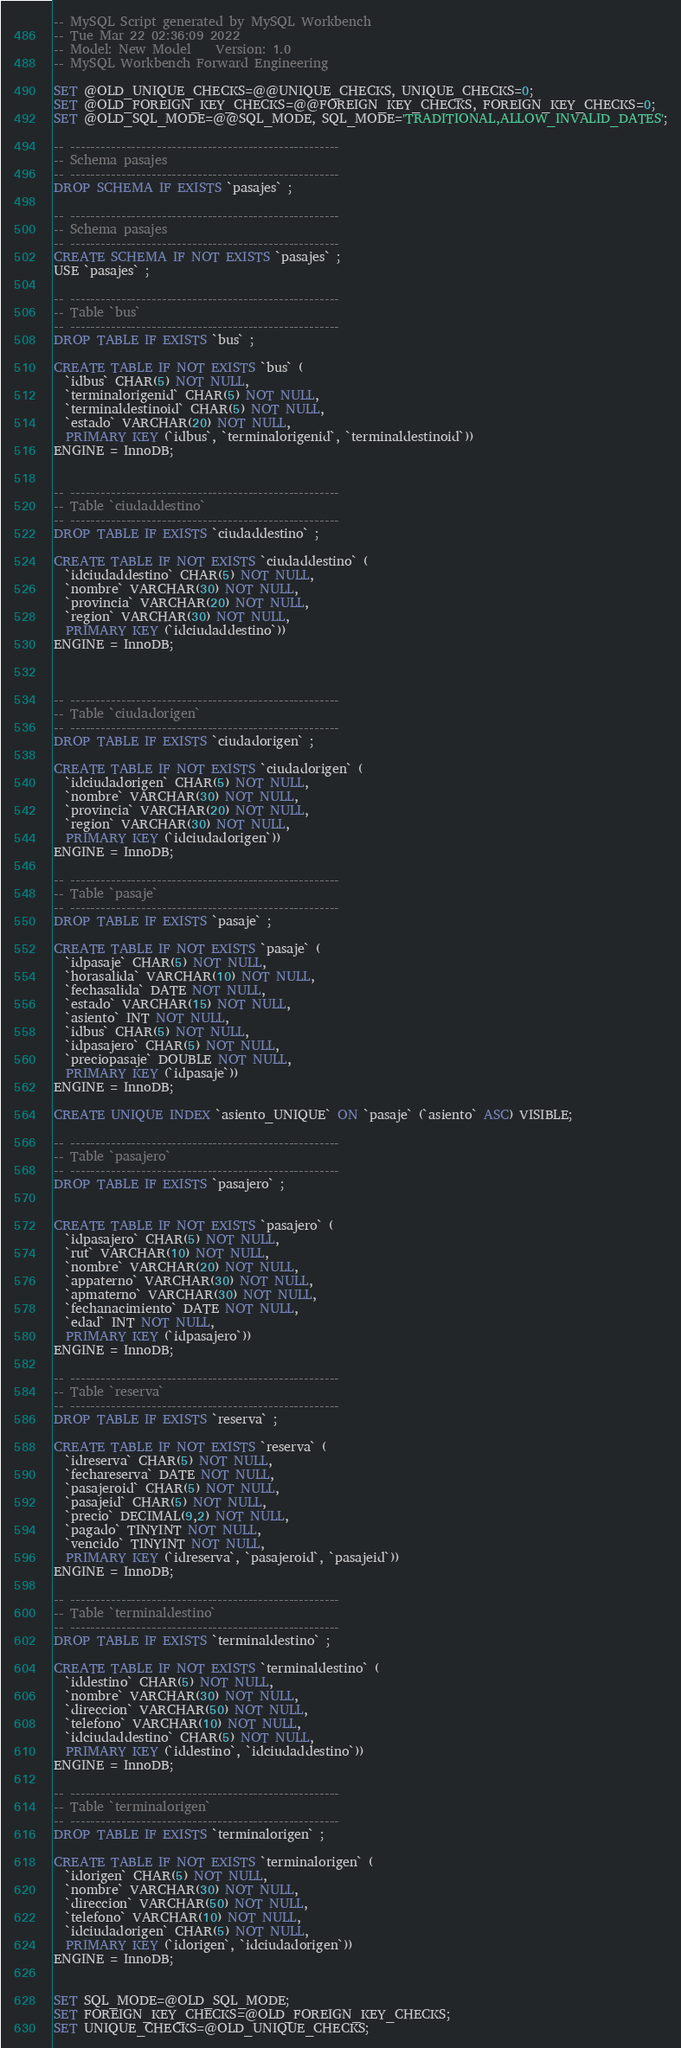Convert code to text. <code><loc_0><loc_0><loc_500><loc_500><_SQL_>-- MySQL Script generated by MySQL Workbench
-- Tue Mar 22 02:36:09 2022
-- Model: New Model    Version: 1.0
-- MySQL Workbench Forward Engineering

SET @OLD_UNIQUE_CHECKS=@@UNIQUE_CHECKS, UNIQUE_CHECKS=0;
SET @OLD_FOREIGN_KEY_CHECKS=@@FOREIGN_KEY_CHECKS, FOREIGN_KEY_CHECKS=0;
SET @OLD_SQL_MODE=@@SQL_MODE, SQL_MODE='TRADITIONAL,ALLOW_INVALID_DATES';

-- -----------------------------------------------------
-- Schema pasajes
-- -----------------------------------------------------
DROP SCHEMA IF EXISTS `pasajes` ;

-- -----------------------------------------------------
-- Schema pasajes
-- -----------------------------------------------------
CREATE SCHEMA IF NOT EXISTS `pasajes` ;
USE `pasajes` ;

-- -----------------------------------------------------
-- Table `bus`
-- -----------------------------------------------------
DROP TABLE IF EXISTS `bus` ;

CREATE TABLE IF NOT EXISTS `bus` (
  `idbus` CHAR(5) NOT NULL,
  `terminalorigenid` CHAR(5) NOT NULL,
  `terminaldestinoid` CHAR(5) NOT NULL,
  `estado` VARCHAR(20) NOT NULL,
  PRIMARY KEY (`idbus`, `terminalorigenid`, `terminaldestinoid`))
ENGINE = InnoDB;


-- -----------------------------------------------------
-- Table `ciudaddestino`
-- -----------------------------------------------------
DROP TABLE IF EXISTS `ciudaddestino` ;

CREATE TABLE IF NOT EXISTS `ciudaddestino` (
  `idciudaddestino` CHAR(5) NOT NULL,
  `nombre` VARCHAR(30) NOT NULL,
  `provincia` VARCHAR(20) NOT NULL,
  `region` VARCHAR(30) NOT NULL,
  PRIMARY KEY (`idciudaddestino`))
ENGINE = InnoDB;



-- -----------------------------------------------------
-- Table `ciudadorigen`
-- -----------------------------------------------------
DROP TABLE IF EXISTS `ciudadorigen` ;

CREATE TABLE IF NOT EXISTS `ciudadorigen` (
  `idciudadorigen` CHAR(5) NOT NULL,
  `nombre` VARCHAR(30) NOT NULL,
  `provincia` VARCHAR(20) NOT NULL,
  `region` VARCHAR(30) NOT NULL,
  PRIMARY KEY (`idciudadorigen`))
ENGINE = InnoDB;

-- -----------------------------------------------------
-- Table `pasaje`
-- -----------------------------------------------------
DROP TABLE IF EXISTS `pasaje` ;

CREATE TABLE IF NOT EXISTS `pasaje` (
  `idpasaje` CHAR(5) NOT NULL,
  `horasalida` VARCHAR(10) NOT NULL,
  `fechasalida` DATE NOT NULL,
  `estado` VARCHAR(15) NOT NULL,
  `asiento` INT NOT NULL,
  `idbus` CHAR(5) NOT NULL,
  `idpasajero` CHAR(5) NOT NULL,
  `preciopasaje` DOUBLE NOT NULL,
  PRIMARY KEY (`idpasaje`))
ENGINE = InnoDB;

CREATE UNIQUE INDEX `asiento_UNIQUE` ON `pasaje` (`asiento` ASC) VISIBLE;

-- -----------------------------------------------------
-- Table `pasajero`
-- -----------------------------------------------------
DROP TABLE IF EXISTS `pasajero` ;


CREATE TABLE IF NOT EXISTS `pasajero` (
  `idpasajero` CHAR(5) NOT NULL,
  `rut` VARCHAR(10) NOT NULL,
  `nombre` VARCHAR(20) NOT NULL,
  `appaterno` VARCHAR(30) NOT NULL,
  `apmaterno` VARCHAR(30) NOT NULL,
  `fechanacimiento` DATE NOT NULL,
  `edad` INT NOT NULL,
  PRIMARY KEY (`idpasajero`))
ENGINE = InnoDB;

-- -----------------------------------------------------
-- Table `reserva`
-- -----------------------------------------------------
DROP TABLE IF EXISTS `reserva` ;

CREATE TABLE IF NOT EXISTS `reserva` (
  `idreserva` CHAR(5) NOT NULL,
  `fechareserva` DATE NOT NULL,
  `pasajeroid` CHAR(5) NOT NULL,
  `pasajeid` CHAR(5) NOT NULL,
  `precio` DECIMAL(9,2) NOT NULL,
  `pagado` TINYINT NOT NULL,
  `vencido` TINYINT NOT NULL,
  PRIMARY KEY (`idreserva`, `pasajeroid`, `pasajeid`))
ENGINE = InnoDB;

-- -----------------------------------------------------
-- Table `terminaldestino`
-- -----------------------------------------------------
DROP TABLE IF EXISTS `terminaldestino` ;

CREATE TABLE IF NOT EXISTS `terminaldestino` (
  `iddestino` CHAR(5) NOT NULL,
  `nombre` VARCHAR(30) NOT NULL,
  `direccion` VARCHAR(50) NOT NULL,
  `telefono` VARCHAR(10) NOT NULL,
  `idciudaddestino` CHAR(5) NOT NULL,
  PRIMARY KEY (`iddestino`, `idciudaddestino`))
ENGINE = InnoDB;

-- -----------------------------------------------------
-- Table `terminalorigen`
-- -----------------------------------------------------
DROP TABLE IF EXISTS `terminalorigen` ;

CREATE TABLE IF NOT EXISTS `terminalorigen` (
  `idorigen` CHAR(5) NOT NULL,
  `nombre` VARCHAR(30) NOT NULL,
  `direccion` VARCHAR(50) NOT NULL,
  `telefono` VARCHAR(10) NOT NULL,
  `idciudadorigen` CHAR(5) NOT NULL,
  PRIMARY KEY (`idorigen`, `idciudadorigen`))
ENGINE = InnoDB;


SET SQL_MODE=@OLD_SQL_MODE;
SET FOREIGN_KEY_CHECKS=@OLD_FOREIGN_KEY_CHECKS;
SET UNIQUE_CHECKS=@OLD_UNIQUE_CHECKS;
</code> 